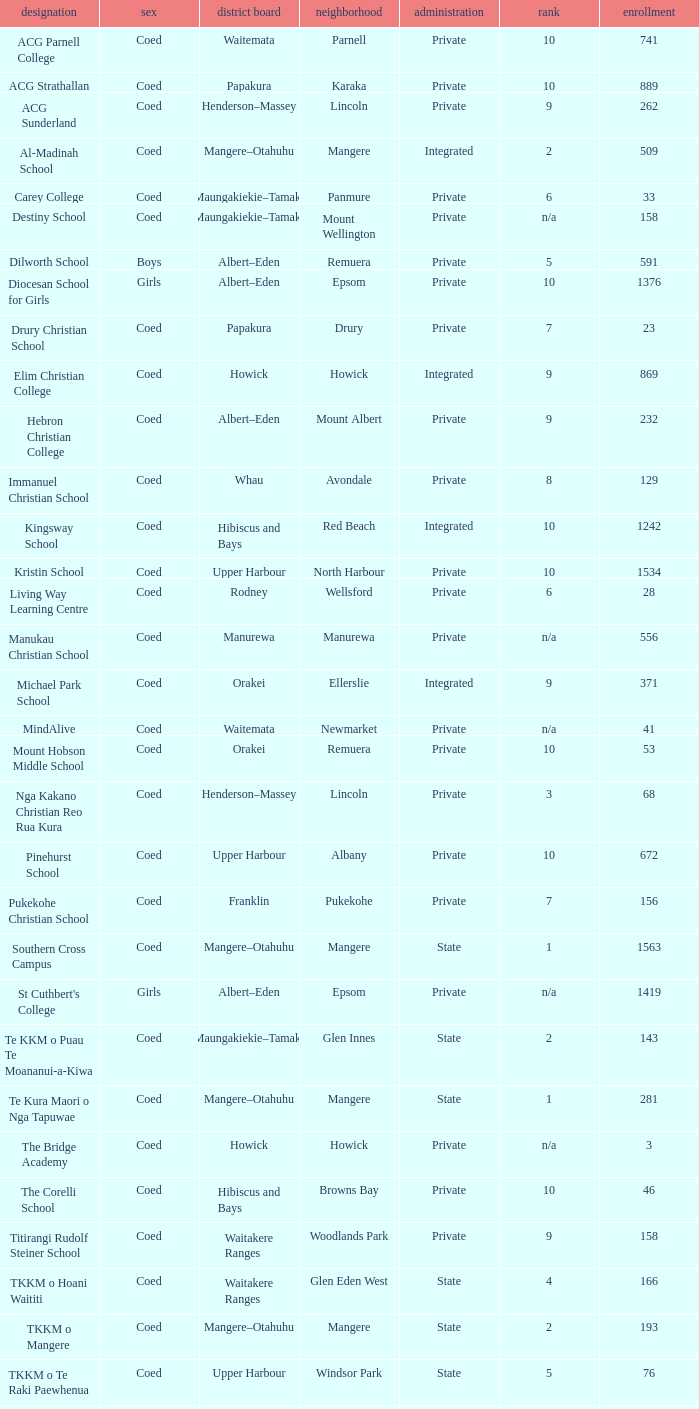What is the name of the suburb with a roll of 741? Parnell. 